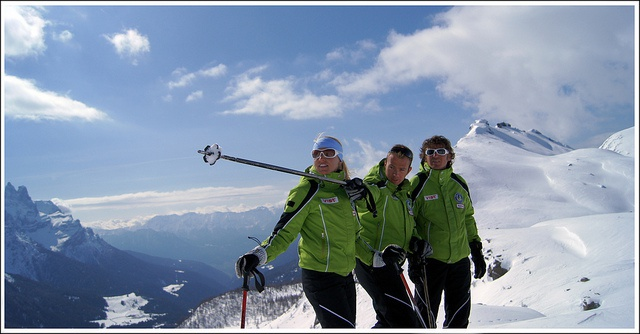Describe the objects in this image and their specific colors. I can see people in black, darkgreen, and gray tones, people in black, darkgreen, and gray tones, and people in black, darkgreen, and maroon tones in this image. 